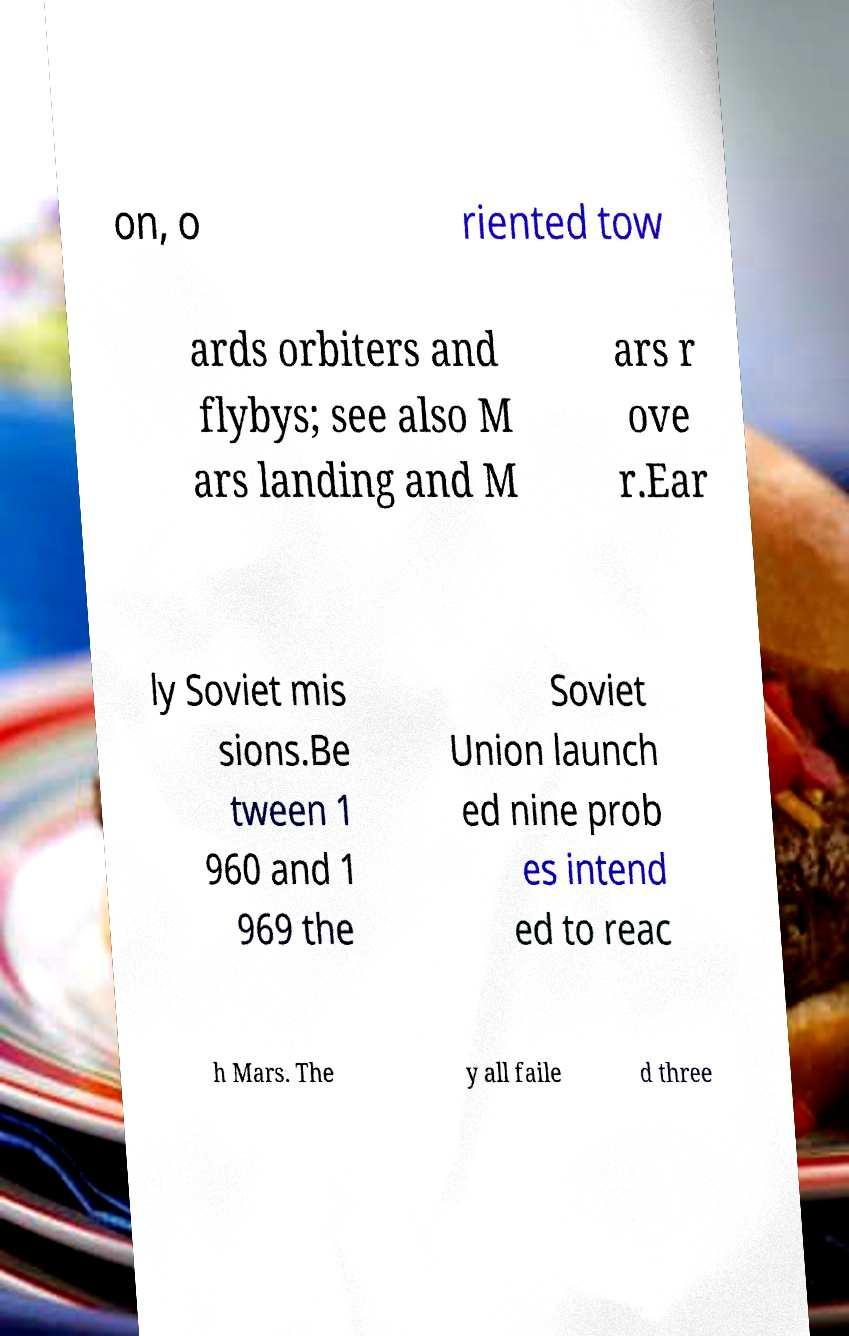Could you extract and type out the text from this image? on, o riented tow ards orbiters and flybys; see also M ars landing and M ars r ove r.Ear ly Soviet mis sions.Be tween 1 960 and 1 969 the Soviet Union launch ed nine prob es intend ed to reac h Mars. The y all faile d three 